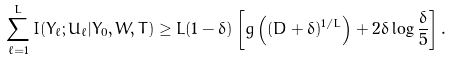Convert formula to latex. <formula><loc_0><loc_0><loc_500><loc_500>\sum _ { \ell = 1 } ^ { L } I ( Y _ { \ell } ; U _ { \ell } | Y _ { 0 } , W , T ) \geq L ( 1 - \delta ) \left [ g \left ( ( D + \delta ) ^ { 1 / L } \right ) + 2 \delta \log \frac { \delta } { 5 } \right ] .</formula> 